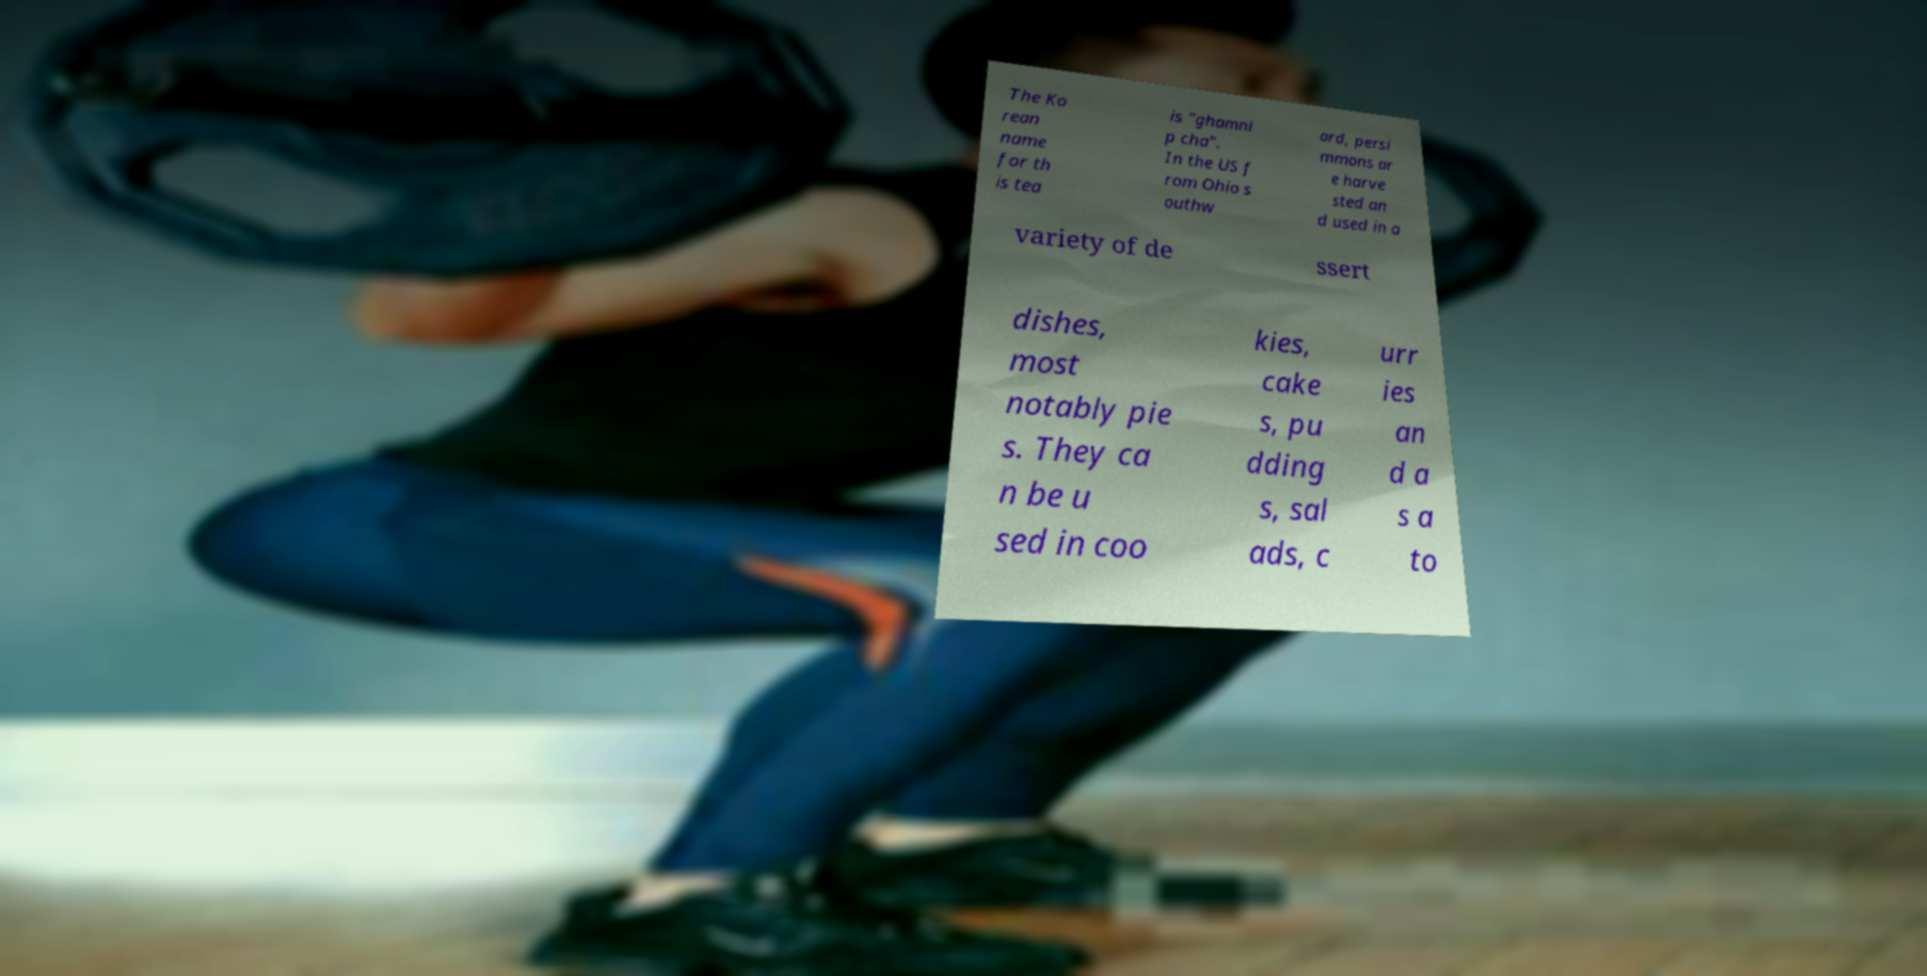For documentation purposes, I need the text within this image transcribed. Could you provide that? The Ko rean name for th is tea is "ghamni p cha". In the US f rom Ohio s outhw ard, persi mmons ar e harve sted an d used in a variety of de ssert dishes, most notably pie s. They ca n be u sed in coo kies, cake s, pu dding s, sal ads, c urr ies an d a s a to 